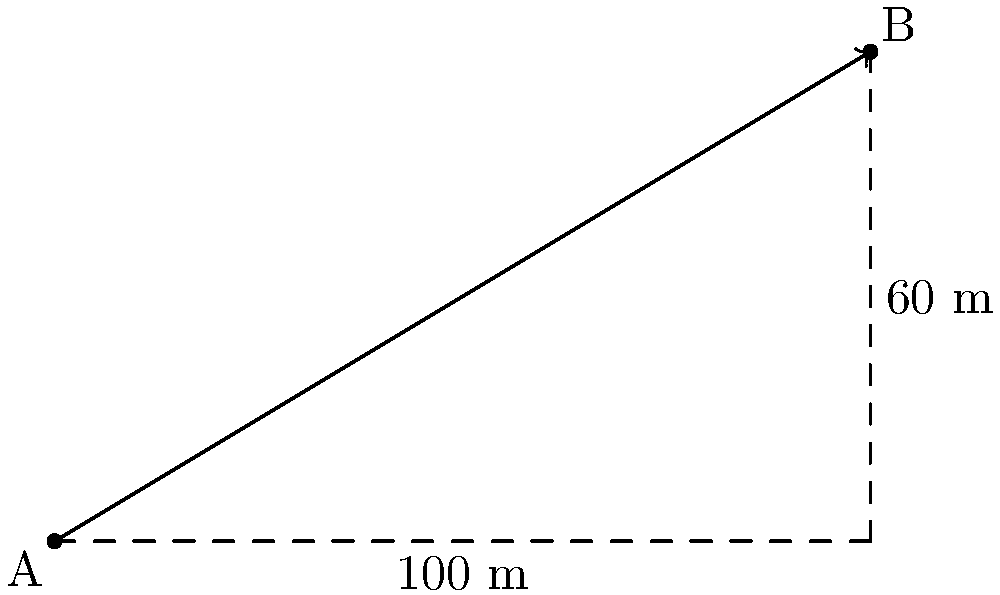A cable needs to be installed between two points A and B on a construction site. Point A is at ground level, and point B is on top of a building. The horizontal distance between the points is 100 meters, and the height difference is 60 meters. Calculate the length of the cable needed to span between these two points. To find the length of the cable, we need to use the Pythagorean theorem, as the cable forms the hypotenuse of a right triangle.

Step 1: Identify the known sides of the triangle
- Horizontal distance (base of the triangle): 100 m
- Vertical distance (height of the triangle): 60 m

Step 2: Apply the Pythagorean theorem
$$c^2 = a^2 + b^2$$
Where:
$c$ is the length of the cable (hypotenuse)
$a$ is the horizontal distance (100 m)
$b$ is the vertical distance (60 m)

Step 3: Substitute the known values
$$c^2 = 100^2 + 60^2$$

Step 4: Calculate
$$c^2 = 10000 + 3600 = 13600$$

Step 5: Take the square root of both sides
$$c = \sqrt{13600}$$

Step 6: Simplify
$$c = 116.62 \text{ m}$$

Therefore, the length of the cable needed is approximately 116.62 meters.
Answer: 116.62 m 